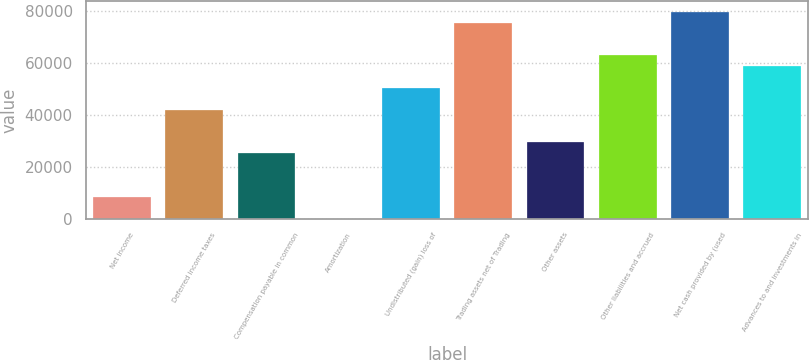<chart> <loc_0><loc_0><loc_500><loc_500><bar_chart><fcel>Net income<fcel>Deferred income taxes<fcel>Compensation payable in common<fcel>Amortization<fcel>Undistributed (gain) loss of<fcel>Trading assets net of Trading<fcel>Other assets<fcel>Other liabilities and accrued<fcel>Net cash provided by (used<fcel>Advances to and investments in<nl><fcel>8401.2<fcel>41914<fcel>25157.6<fcel>23<fcel>50292.2<fcel>75426.8<fcel>29346.7<fcel>62859.5<fcel>79615.9<fcel>58670.4<nl></chart> 